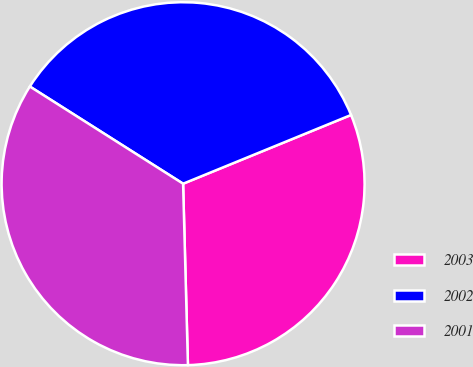<chart> <loc_0><loc_0><loc_500><loc_500><pie_chart><fcel>2003<fcel>2002<fcel>2001<nl><fcel>30.76%<fcel>34.82%<fcel>34.42%<nl></chart> 